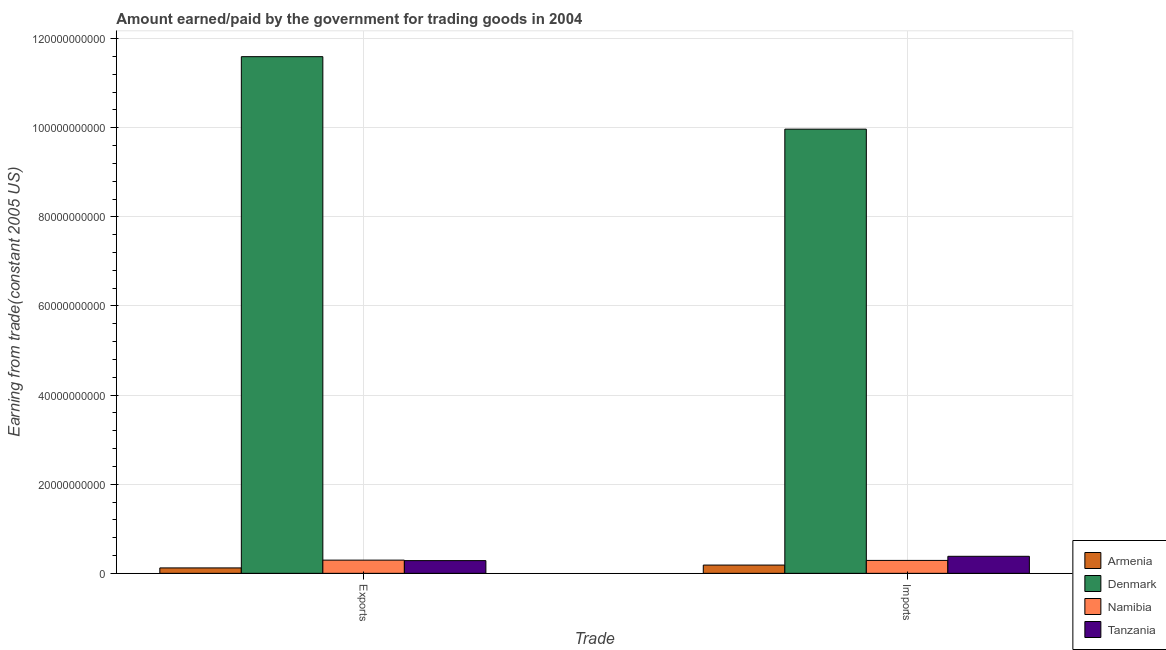How many different coloured bars are there?
Your answer should be very brief. 4. How many groups of bars are there?
Offer a very short reply. 2. How many bars are there on the 1st tick from the left?
Your answer should be compact. 4. What is the label of the 1st group of bars from the left?
Make the answer very short. Exports. What is the amount earned from exports in Denmark?
Ensure brevity in your answer.  1.16e+11. Across all countries, what is the maximum amount earned from exports?
Your answer should be very brief. 1.16e+11. Across all countries, what is the minimum amount earned from exports?
Provide a succinct answer. 1.22e+09. In which country was the amount paid for imports minimum?
Offer a very short reply. Armenia. What is the total amount paid for imports in the graph?
Ensure brevity in your answer.  1.08e+11. What is the difference between the amount paid for imports in Namibia and that in Tanzania?
Provide a succinct answer. -9.20e+08. What is the difference between the amount paid for imports in Denmark and the amount earned from exports in Tanzania?
Offer a terse response. 9.68e+1. What is the average amount earned from exports per country?
Keep it short and to the point. 3.07e+1. What is the difference between the amount paid for imports and amount earned from exports in Armenia?
Your answer should be compact. 6.36e+08. What is the ratio of the amount paid for imports in Denmark to that in Tanzania?
Your response must be concise. 26.09. What does the 1st bar from the left in Exports represents?
Keep it short and to the point. Armenia. How many bars are there?
Offer a terse response. 8. How many countries are there in the graph?
Your response must be concise. 4. What is the difference between two consecutive major ticks on the Y-axis?
Offer a terse response. 2.00e+1. Where does the legend appear in the graph?
Offer a terse response. Bottom right. How are the legend labels stacked?
Provide a short and direct response. Vertical. What is the title of the graph?
Offer a terse response. Amount earned/paid by the government for trading goods in 2004. Does "Zimbabwe" appear as one of the legend labels in the graph?
Offer a very short reply. No. What is the label or title of the X-axis?
Provide a short and direct response. Trade. What is the label or title of the Y-axis?
Offer a terse response. Earning from trade(constant 2005 US). What is the Earning from trade(constant 2005 US) in Armenia in Exports?
Ensure brevity in your answer.  1.22e+09. What is the Earning from trade(constant 2005 US) of Denmark in Exports?
Offer a very short reply. 1.16e+11. What is the Earning from trade(constant 2005 US) of Namibia in Exports?
Offer a very short reply. 2.96e+09. What is the Earning from trade(constant 2005 US) in Tanzania in Exports?
Provide a succinct answer. 2.85e+09. What is the Earning from trade(constant 2005 US) in Armenia in Imports?
Your response must be concise. 1.85e+09. What is the Earning from trade(constant 2005 US) of Denmark in Imports?
Ensure brevity in your answer.  9.97e+1. What is the Earning from trade(constant 2005 US) of Namibia in Imports?
Your response must be concise. 2.90e+09. What is the Earning from trade(constant 2005 US) in Tanzania in Imports?
Offer a terse response. 3.82e+09. Across all Trade, what is the maximum Earning from trade(constant 2005 US) of Armenia?
Make the answer very short. 1.85e+09. Across all Trade, what is the maximum Earning from trade(constant 2005 US) of Denmark?
Offer a terse response. 1.16e+11. Across all Trade, what is the maximum Earning from trade(constant 2005 US) of Namibia?
Keep it short and to the point. 2.96e+09. Across all Trade, what is the maximum Earning from trade(constant 2005 US) of Tanzania?
Make the answer very short. 3.82e+09. Across all Trade, what is the minimum Earning from trade(constant 2005 US) in Armenia?
Offer a very short reply. 1.22e+09. Across all Trade, what is the minimum Earning from trade(constant 2005 US) of Denmark?
Offer a terse response. 9.97e+1. Across all Trade, what is the minimum Earning from trade(constant 2005 US) of Namibia?
Provide a succinct answer. 2.90e+09. Across all Trade, what is the minimum Earning from trade(constant 2005 US) of Tanzania?
Provide a short and direct response. 2.85e+09. What is the total Earning from trade(constant 2005 US) in Armenia in the graph?
Ensure brevity in your answer.  3.07e+09. What is the total Earning from trade(constant 2005 US) of Denmark in the graph?
Provide a short and direct response. 2.16e+11. What is the total Earning from trade(constant 2005 US) of Namibia in the graph?
Your answer should be very brief. 5.86e+09. What is the total Earning from trade(constant 2005 US) of Tanzania in the graph?
Offer a terse response. 6.67e+09. What is the difference between the Earning from trade(constant 2005 US) of Armenia in Exports and that in Imports?
Provide a succinct answer. -6.36e+08. What is the difference between the Earning from trade(constant 2005 US) in Denmark in Exports and that in Imports?
Offer a very short reply. 1.63e+1. What is the difference between the Earning from trade(constant 2005 US) in Namibia in Exports and that in Imports?
Provide a succinct answer. 6.14e+07. What is the difference between the Earning from trade(constant 2005 US) of Tanzania in Exports and that in Imports?
Your answer should be very brief. -9.67e+08. What is the difference between the Earning from trade(constant 2005 US) in Armenia in Exports and the Earning from trade(constant 2005 US) in Denmark in Imports?
Your answer should be very brief. -9.85e+1. What is the difference between the Earning from trade(constant 2005 US) of Armenia in Exports and the Earning from trade(constant 2005 US) of Namibia in Imports?
Your answer should be compact. -1.68e+09. What is the difference between the Earning from trade(constant 2005 US) of Armenia in Exports and the Earning from trade(constant 2005 US) of Tanzania in Imports?
Ensure brevity in your answer.  -2.60e+09. What is the difference between the Earning from trade(constant 2005 US) in Denmark in Exports and the Earning from trade(constant 2005 US) in Namibia in Imports?
Keep it short and to the point. 1.13e+11. What is the difference between the Earning from trade(constant 2005 US) of Denmark in Exports and the Earning from trade(constant 2005 US) of Tanzania in Imports?
Provide a short and direct response. 1.12e+11. What is the difference between the Earning from trade(constant 2005 US) of Namibia in Exports and the Earning from trade(constant 2005 US) of Tanzania in Imports?
Provide a succinct answer. -8.59e+08. What is the average Earning from trade(constant 2005 US) in Armenia per Trade?
Your response must be concise. 1.54e+09. What is the average Earning from trade(constant 2005 US) of Denmark per Trade?
Provide a short and direct response. 1.08e+11. What is the average Earning from trade(constant 2005 US) of Namibia per Trade?
Offer a terse response. 2.93e+09. What is the average Earning from trade(constant 2005 US) in Tanzania per Trade?
Offer a very short reply. 3.34e+09. What is the difference between the Earning from trade(constant 2005 US) of Armenia and Earning from trade(constant 2005 US) of Denmark in Exports?
Make the answer very short. -1.15e+11. What is the difference between the Earning from trade(constant 2005 US) of Armenia and Earning from trade(constant 2005 US) of Namibia in Exports?
Your answer should be compact. -1.74e+09. What is the difference between the Earning from trade(constant 2005 US) in Armenia and Earning from trade(constant 2005 US) in Tanzania in Exports?
Provide a short and direct response. -1.64e+09. What is the difference between the Earning from trade(constant 2005 US) in Denmark and Earning from trade(constant 2005 US) in Namibia in Exports?
Give a very brief answer. 1.13e+11. What is the difference between the Earning from trade(constant 2005 US) in Denmark and Earning from trade(constant 2005 US) in Tanzania in Exports?
Keep it short and to the point. 1.13e+11. What is the difference between the Earning from trade(constant 2005 US) in Namibia and Earning from trade(constant 2005 US) in Tanzania in Exports?
Provide a short and direct response. 1.09e+08. What is the difference between the Earning from trade(constant 2005 US) in Armenia and Earning from trade(constant 2005 US) in Denmark in Imports?
Give a very brief answer. -9.78e+1. What is the difference between the Earning from trade(constant 2005 US) in Armenia and Earning from trade(constant 2005 US) in Namibia in Imports?
Your answer should be compact. -1.05e+09. What is the difference between the Earning from trade(constant 2005 US) in Armenia and Earning from trade(constant 2005 US) in Tanzania in Imports?
Ensure brevity in your answer.  -1.97e+09. What is the difference between the Earning from trade(constant 2005 US) of Denmark and Earning from trade(constant 2005 US) of Namibia in Imports?
Offer a very short reply. 9.68e+1. What is the difference between the Earning from trade(constant 2005 US) of Denmark and Earning from trade(constant 2005 US) of Tanzania in Imports?
Your answer should be very brief. 9.59e+1. What is the difference between the Earning from trade(constant 2005 US) in Namibia and Earning from trade(constant 2005 US) in Tanzania in Imports?
Your response must be concise. -9.20e+08. What is the ratio of the Earning from trade(constant 2005 US) of Armenia in Exports to that in Imports?
Offer a terse response. 0.66. What is the ratio of the Earning from trade(constant 2005 US) in Denmark in Exports to that in Imports?
Offer a very short reply. 1.16. What is the ratio of the Earning from trade(constant 2005 US) in Namibia in Exports to that in Imports?
Your answer should be compact. 1.02. What is the ratio of the Earning from trade(constant 2005 US) in Tanzania in Exports to that in Imports?
Offer a very short reply. 0.75. What is the difference between the highest and the second highest Earning from trade(constant 2005 US) in Armenia?
Your answer should be compact. 6.36e+08. What is the difference between the highest and the second highest Earning from trade(constant 2005 US) in Denmark?
Your answer should be very brief. 1.63e+1. What is the difference between the highest and the second highest Earning from trade(constant 2005 US) of Namibia?
Offer a terse response. 6.14e+07. What is the difference between the highest and the second highest Earning from trade(constant 2005 US) in Tanzania?
Make the answer very short. 9.67e+08. What is the difference between the highest and the lowest Earning from trade(constant 2005 US) of Armenia?
Your answer should be very brief. 6.36e+08. What is the difference between the highest and the lowest Earning from trade(constant 2005 US) of Denmark?
Give a very brief answer. 1.63e+1. What is the difference between the highest and the lowest Earning from trade(constant 2005 US) of Namibia?
Make the answer very short. 6.14e+07. What is the difference between the highest and the lowest Earning from trade(constant 2005 US) of Tanzania?
Offer a very short reply. 9.67e+08. 